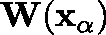Convert formula to latex. <formula><loc_0><loc_0><loc_500><loc_500>W ( x _ { \alpha } )</formula> 